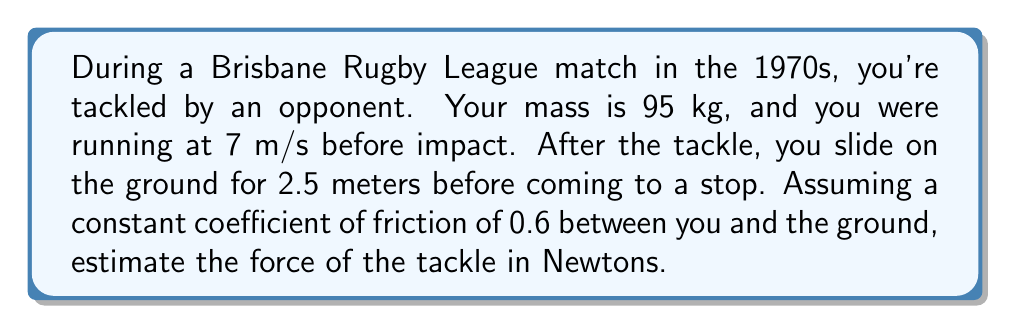Can you solve this math problem? To solve this problem, we'll use the work-energy principle and Newton's Second Law. Let's break it down step-by-step:

1) First, calculate your initial kinetic energy:
   $KE_i = \frac{1}{2}mv^2 = \frac{1}{2} \cdot 95 \cdot 7^2 = 2327.5$ J

2) After the tackle, all your kinetic energy is converted to work done against friction:
   $W_f = KE_i = 2327.5$ J

3) The work done by friction is equal to the friction force times the distance:
   $W_f = F_f \cdot d$
   where $F_f$ is the friction force and $d$ is the sliding distance.

4) The friction force is related to the normal force by:
   $F_f = \mu F_N$
   where $\mu$ is the coefficient of friction and $F_N$ is the normal force.

5) The normal force is equal to your weight:
   $F_N = mg = 95 \cdot 9.8 = 931$ N

6) Now we can calculate the friction force:
   $F_f = 0.6 \cdot 931 = 558.6$ N

7) Using the work-friction equation:
   $2327.5 = 558.6 \cdot 2.5$
   $2327.5 = 1396.5$

8) The difference between these energies is the work done by the tackle:
   $W_t = 2327.5 - 1396.5 = 931$ J

9) Assuming the tackle acts over a short distance (let's say 0.5 m), we can estimate the average force:
   $F_t = \frac{W_t}{d_t} = \frac{931}{0.5} = 1862$ N

Therefore, the estimated force of the tackle is approximately 1862 N.
Answer: 1862 N 